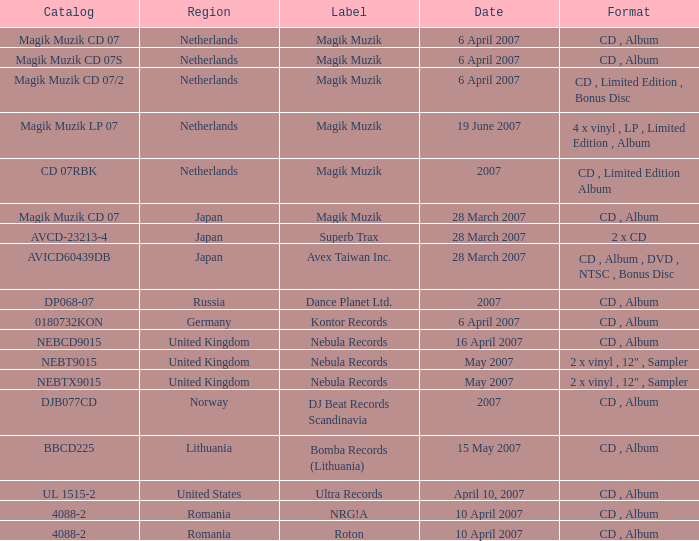Which label released the catalog Magik Muzik CD 07 on 28 March 2007? Magik Muzik. 